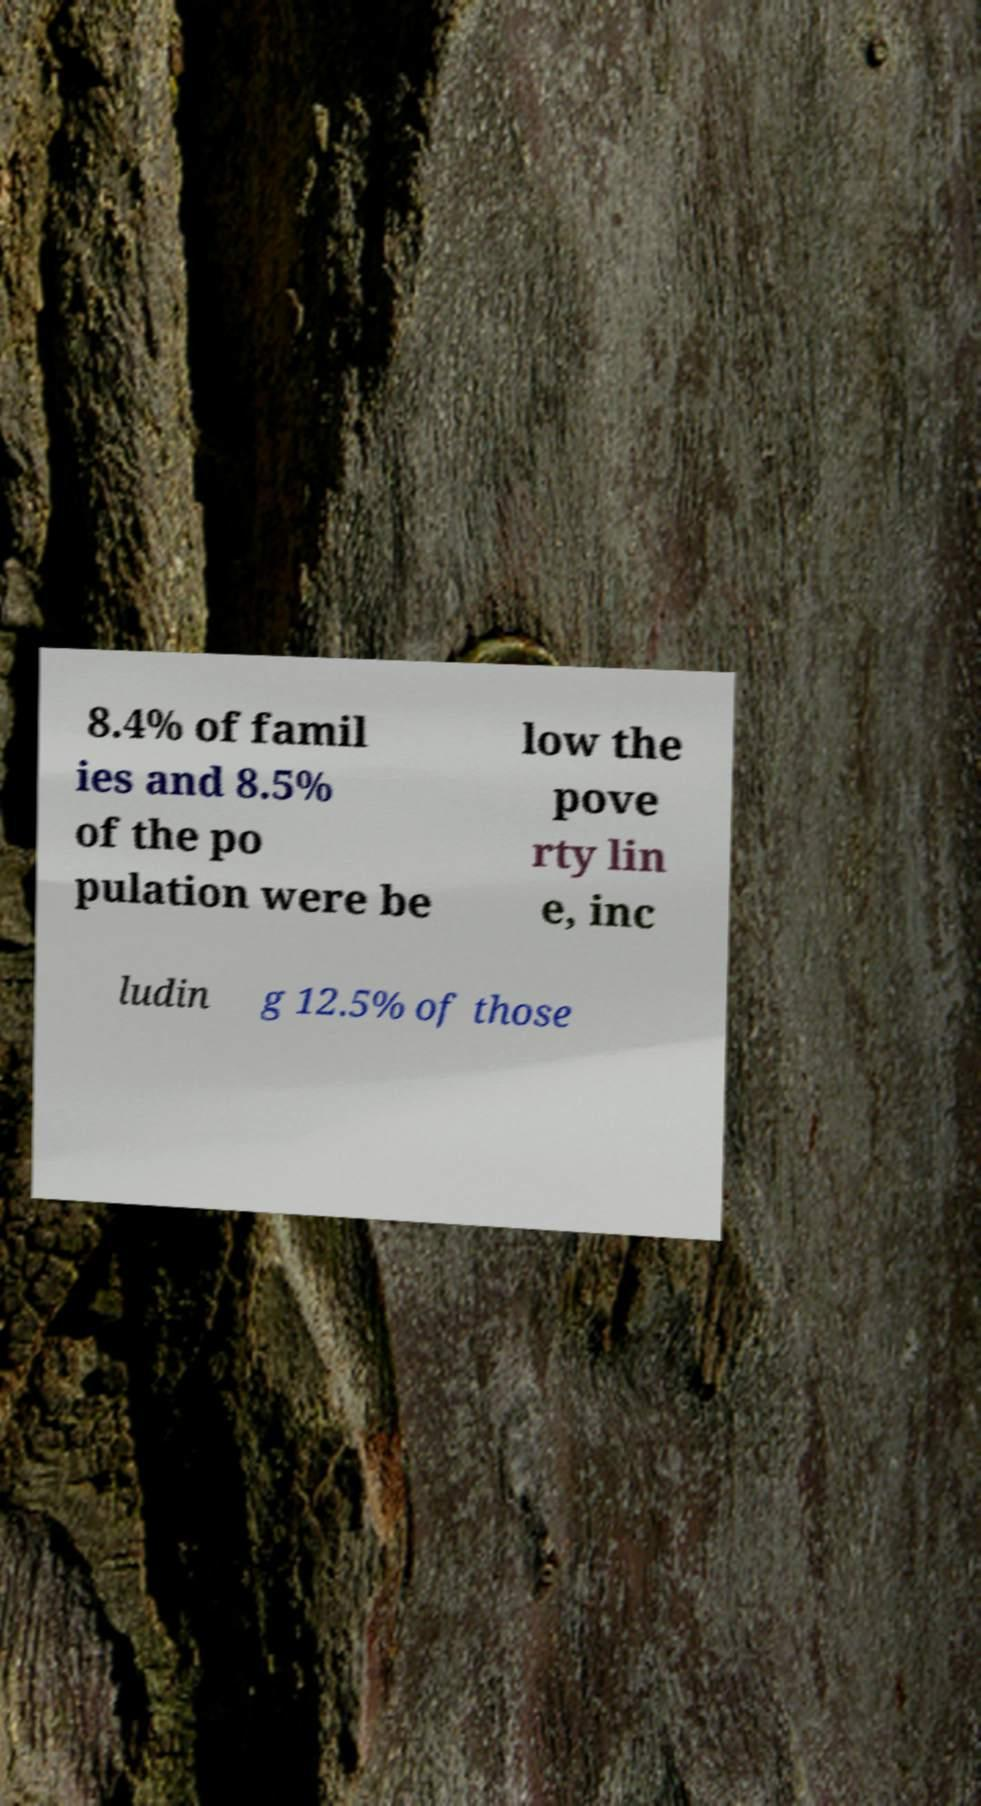I need the written content from this picture converted into text. Can you do that? 8.4% of famil ies and 8.5% of the po pulation were be low the pove rty lin e, inc ludin g 12.5% of those 